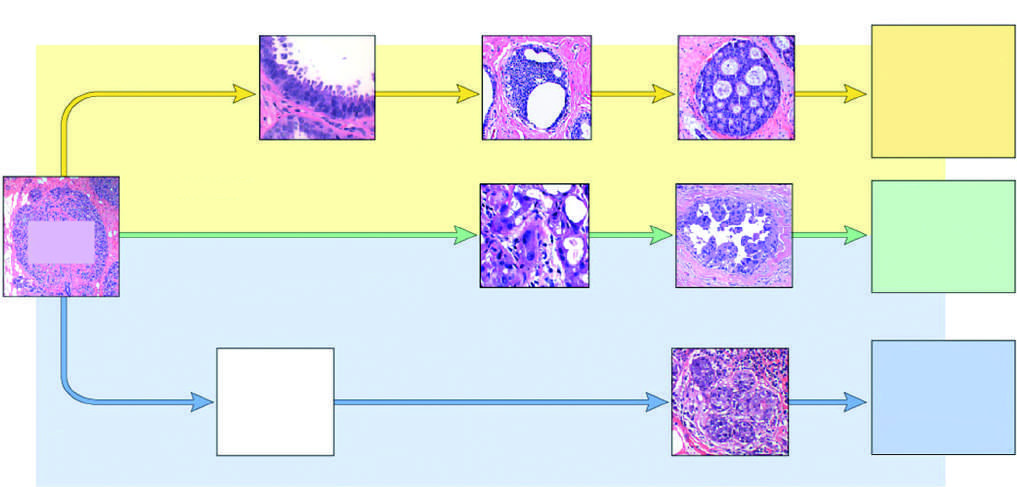what is the type of cancer that arises most commonly in individuals with germline brca2 mutations?
Answer the question using a single word or phrase. Luminal 